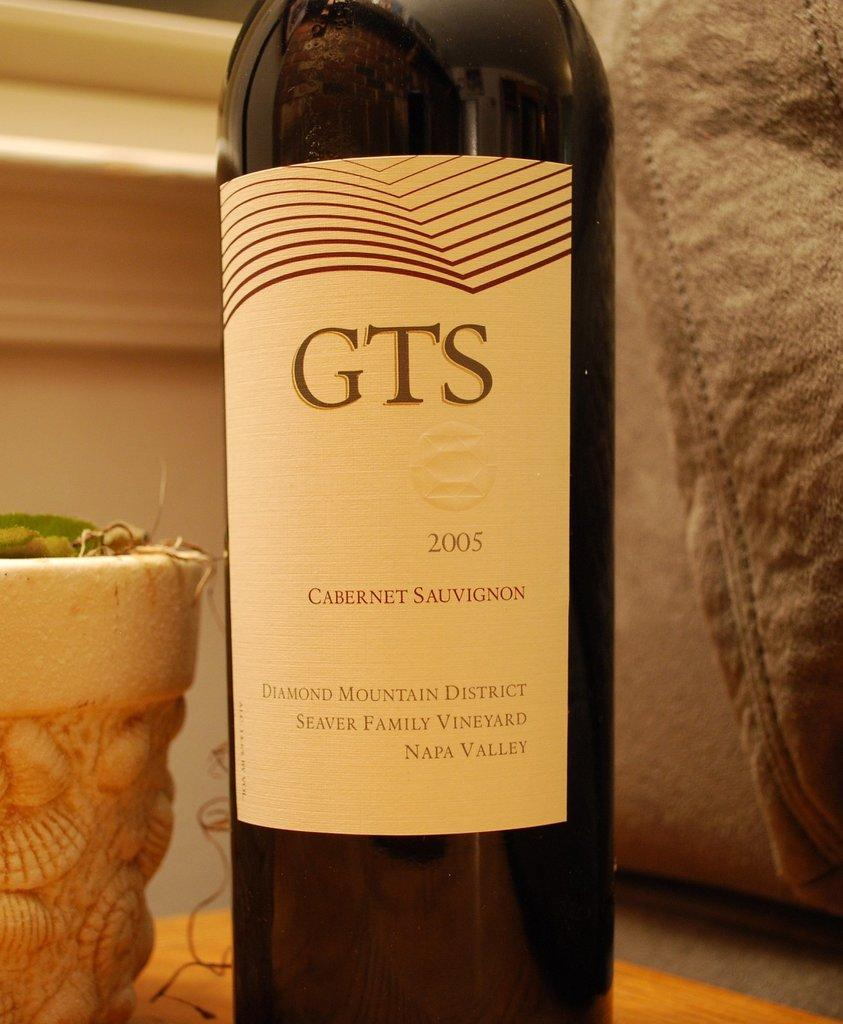Provide a one-sentence caption for the provided image. A bottle of GTS 2005 Cabernet Sauvignon from the Diamond Mountain District. 